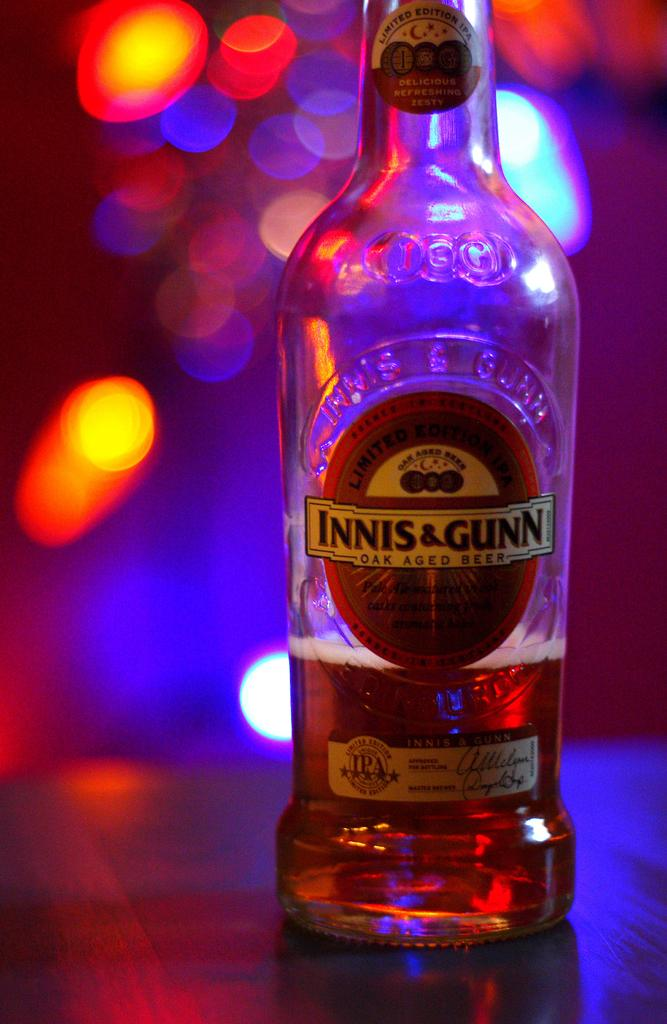<image>
Relay a brief, clear account of the picture shown. A bottle of alcohol with the words Innis and Gunn on it. 